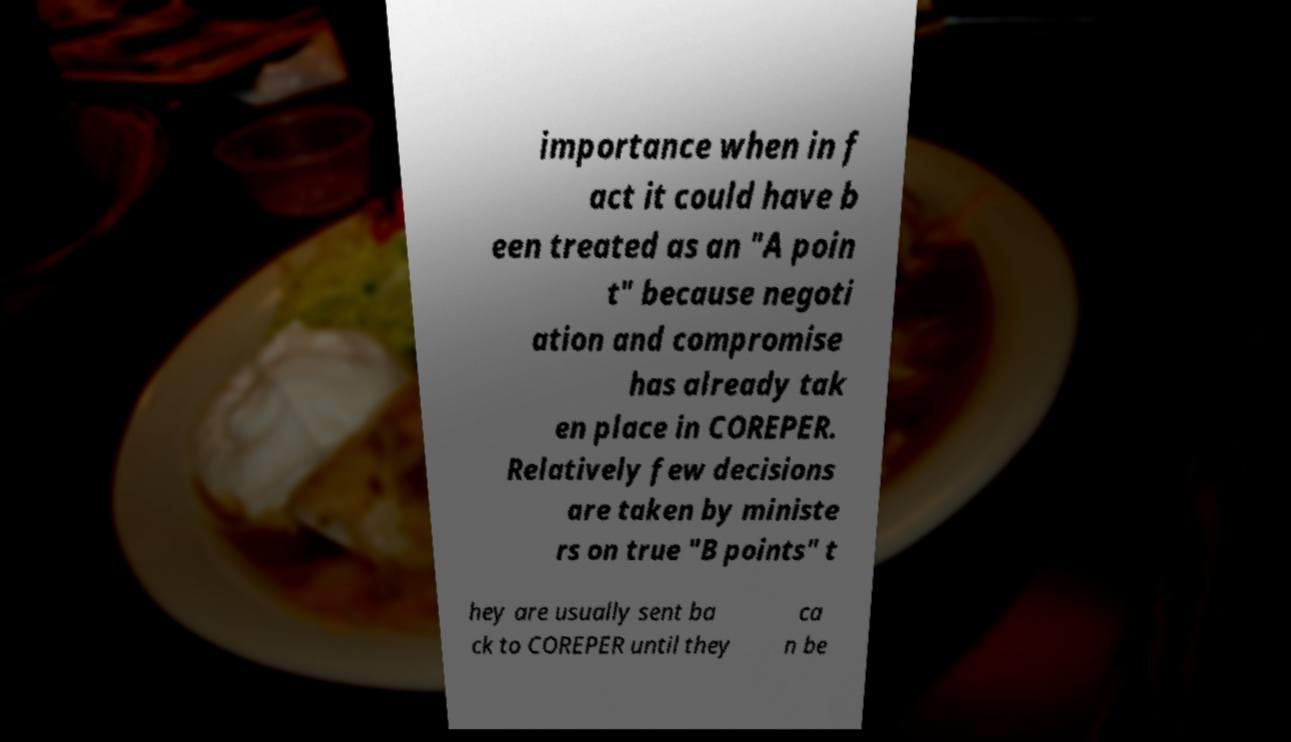I need the written content from this picture converted into text. Can you do that? importance when in f act it could have b een treated as an "A poin t" because negoti ation and compromise has already tak en place in COREPER. Relatively few decisions are taken by ministe rs on true "B points" t hey are usually sent ba ck to COREPER until they ca n be 